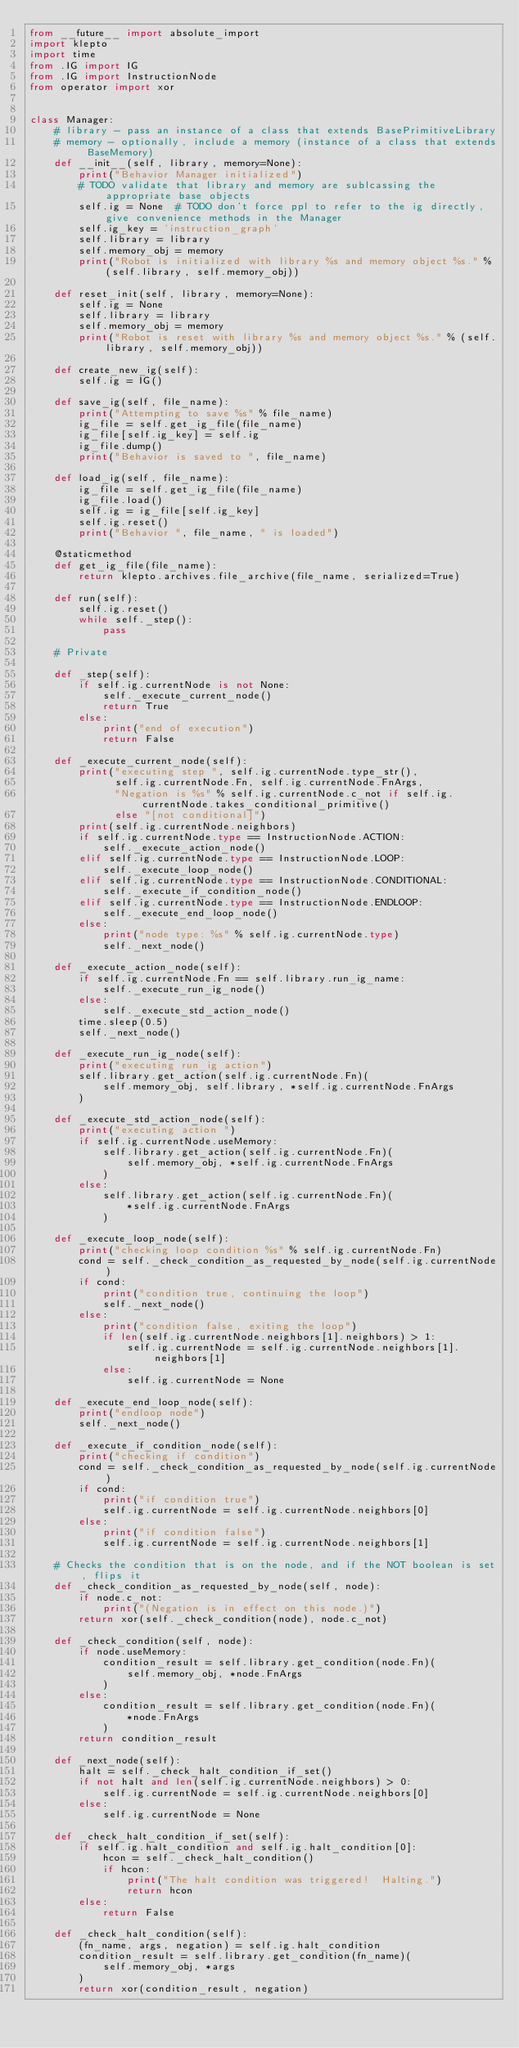Convert code to text. <code><loc_0><loc_0><loc_500><loc_500><_Python_>from __future__ import absolute_import
import klepto
import time
from .IG import IG
from .IG import InstructionNode
from operator import xor


class Manager:
    # library - pass an instance of a class that extends BasePrimitiveLibrary
    # memory - optionally, include a memory (instance of a class that extends BaseMemory)
    def __init__(self, library, memory=None):
        print("Behavior Manager initialized")
        # TODO validate that library and memory are sublcassing the appropriate base objects
        self.ig = None  # TODO don't force ppl to refer to the ig directly, give convenience methods in the Manager
        self.ig_key = 'instruction_graph'
        self.library = library
        self.memory_obj = memory
        print("Robot is initialized with library %s and memory object %s." % (self.library, self.memory_obj))

    def reset_init(self, library, memory=None):
        self.ig = None
        self.library = library
        self.memory_obj = memory
        print("Robot is reset with library %s and memory object %s." % (self.library, self.memory_obj))

    def create_new_ig(self):
        self.ig = IG()

    def save_ig(self, file_name):
        print("Attempting to save %s" % file_name)
        ig_file = self.get_ig_file(file_name)
        ig_file[self.ig_key] = self.ig
        ig_file.dump()
        print("Behavior is saved to ", file_name)

    def load_ig(self, file_name):
        ig_file = self.get_ig_file(file_name)
        ig_file.load()
        self.ig = ig_file[self.ig_key]
        self.ig.reset()
        print("Behavior ", file_name, " is loaded")

    @staticmethod
    def get_ig_file(file_name):
        return klepto.archives.file_archive(file_name, serialized=True)

    def run(self):
        self.ig.reset()
        while self._step():
            pass

    # Private

    def _step(self):
        if self.ig.currentNode is not None:
            self._execute_current_node()
            return True
        else:
            print("end of execution")
            return False

    def _execute_current_node(self):
        print("executing step ", self.ig.currentNode.type_str(),
              self.ig.currentNode.Fn, self.ig.currentNode.FnArgs,
              "Negation is %s" % self.ig.currentNode.c_not if self.ig.currentNode.takes_conditional_primitive()
              else "[not conditional]")
        print(self.ig.currentNode.neighbors)
        if self.ig.currentNode.type == InstructionNode.ACTION:
            self._execute_action_node()
        elif self.ig.currentNode.type == InstructionNode.LOOP:
            self._execute_loop_node()
        elif self.ig.currentNode.type == InstructionNode.CONDITIONAL:
            self._execute_if_condition_node()
        elif self.ig.currentNode.type == InstructionNode.ENDLOOP:
            self._execute_end_loop_node()
        else:
            print("node type: %s" % self.ig.currentNode.type)
            self._next_node()

    def _execute_action_node(self):
        if self.ig.currentNode.Fn == self.library.run_ig_name:
            self._execute_run_ig_node()
        else:
            self._execute_std_action_node()
        time.sleep(0.5)
        self._next_node()

    def _execute_run_ig_node(self):
        print("executing run_ig action")
        self.library.get_action(self.ig.currentNode.Fn)(
            self.memory_obj, self.library, *self.ig.currentNode.FnArgs
        )

    def _execute_std_action_node(self):
        print("executing action ")
        if self.ig.currentNode.useMemory:
            self.library.get_action(self.ig.currentNode.Fn)(
                self.memory_obj, *self.ig.currentNode.FnArgs
            )
        else:
            self.library.get_action(self.ig.currentNode.Fn)(
                *self.ig.currentNode.FnArgs
            )

    def _execute_loop_node(self):
        print("checking loop condition %s" % self.ig.currentNode.Fn)
        cond = self._check_condition_as_requested_by_node(self.ig.currentNode)
        if cond:
            print("condition true, continuing the loop")
            self._next_node()
        else:
            print("condition false, exiting the loop")
            if len(self.ig.currentNode.neighbors[1].neighbors) > 1:
                self.ig.currentNode = self.ig.currentNode.neighbors[1].neighbors[1]
            else:
                self.ig.currentNode = None

    def _execute_end_loop_node(self):
        print("endloop node")
        self._next_node()

    def _execute_if_condition_node(self):
        print("checking if condition")
        cond = self._check_condition_as_requested_by_node(self.ig.currentNode)
        if cond:
            print("if condition true")
            self.ig.currentNode = self.ig.currentNode.neighbors[0]
        else:
            print("if condition false")
            self.ig.currentNode = self.ig.currentNode.neighbors[1]

    # Checks the condition that is on the node, and if the NOT boolean is set, flips it
    def _check_condition_as_requested_by_node(self, node):
        if node.c_not:
            print("(Negation is in effect on this node.)")
        return xor(self._check_condition(node), node.c_not)

    def _check_condition(self, node):
        if node.useMemory:
            condition_result = self.library.get_condition(node.Fn)(
                self.memory_obj, *node.FnArgs
            )
        else:
            condition_result = self.library.get_condition(node.Fn)(
                *node.FnArgs
            )
        return condition_result

    def _next_node(self):
        halt = self._check_halt_condition_if_set()
        if not halt and len(self.ig.currentNode.neighbors) > 0:
            self.ig.currentNode = self.ig.currentNode.neighbors[0]
        else:
            self.ig.currentNode = None

    def _check_halt_condition_if_set(self):
        if self.ig.halt_condition and self.ig.halt_condition[0]:
            hcon = self._check_halt_condition()
            if hcon:
                print("The halt condition was triggered!  Halting.")
                return hcon
        else:
            return False

    def _check_halt_condition(self):
        (fn_name, args, negation) = self.ig.halt_condition
        condition_result = self.library.get_condition(fn_name)(
            self.memory_obj, *args
        )
        return xor(condition_result, negation)
</code> 